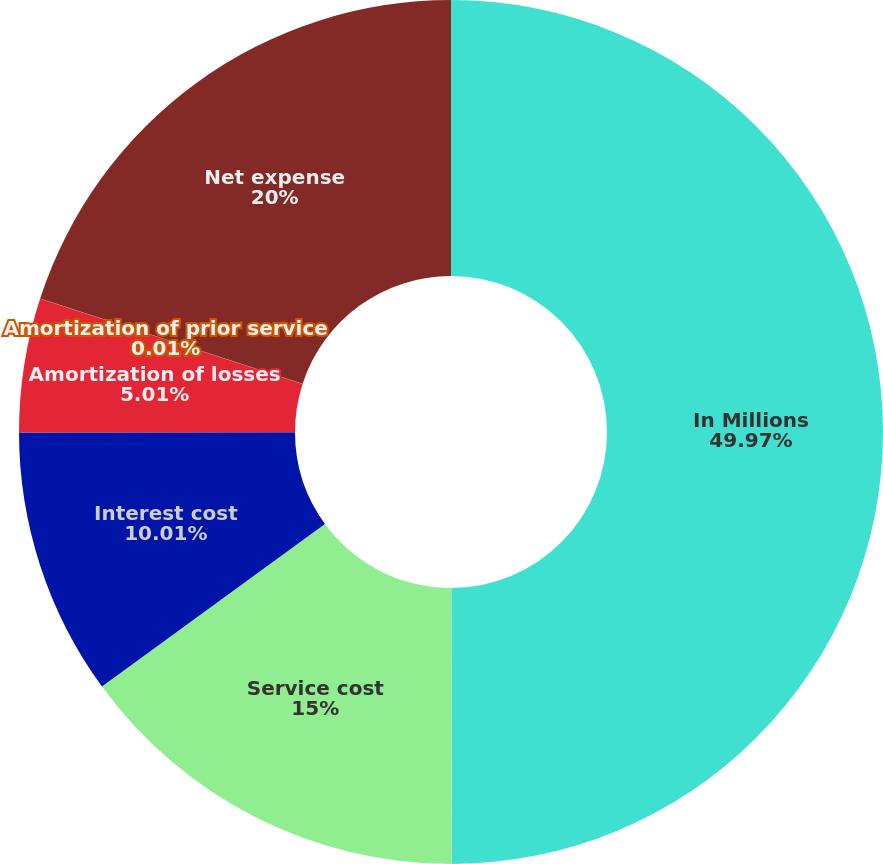<chart> <loc_0><loc_0><loc_500><loc_500><pie_chart><fcel>In Millions<fcel>Service cost<fcel>Interest cost<fcel>Amortization of losses<fcel>Amortization of prior service<fcel>Net expense<nl><fcel>49.97%<fcel>15.0%<fcel>10.01%<fcel>5.01%<fcel>0.01%<fcel>20.0%<nl></chart> 